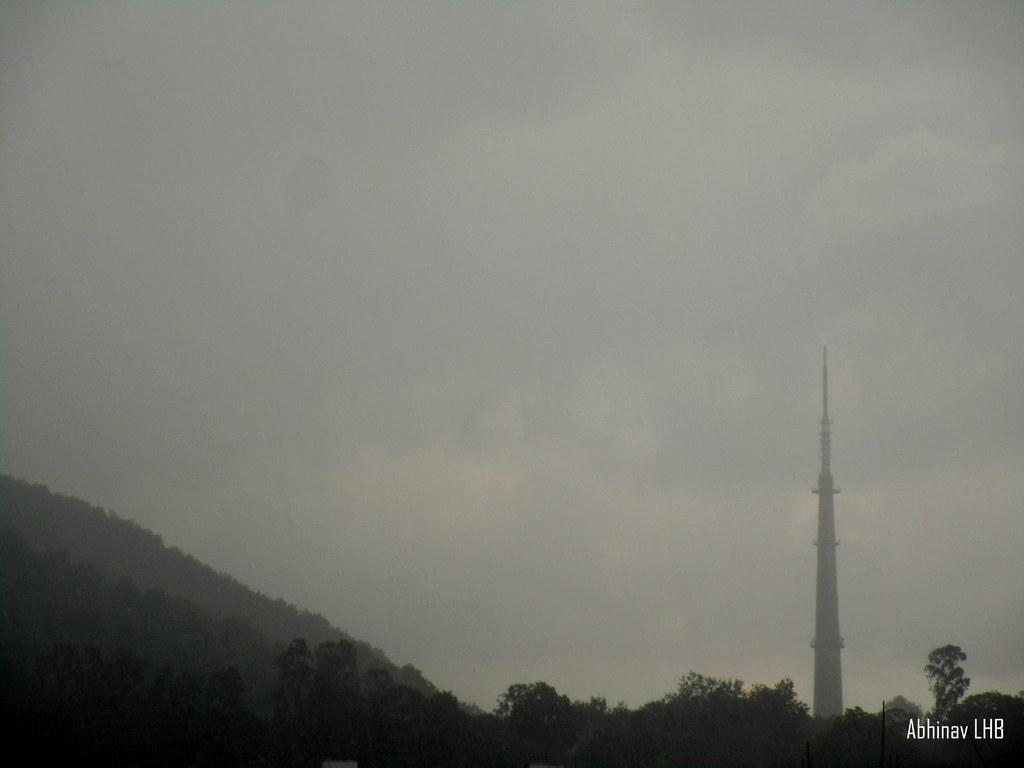What type of vegetation is present in the image? There are many trees in the image. What structure can be seen on the right side of the image? There is a tower on the right side of the image. What geographical feature is on the left side of the image? There appears to be a mountain on the left side of the image. What is visible at the top of the image? The sky is visible at the top of the image. What can be seen in the sky? There are clouds in the sky. Who is the writer in the image? There is no writer present in the image. What type of development can be seen in the image? There is no development or construction project visible in the image. 